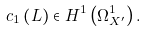Convert formula to latex. <formula><loc_0><loc_0><loc_500><loc_500>c _ { 1 } \left ( L \right ) \in H ^ { 1 } \left ( \Omega _ { X ^ { \prime } } ^ { 1 } \right ) .</formula> 